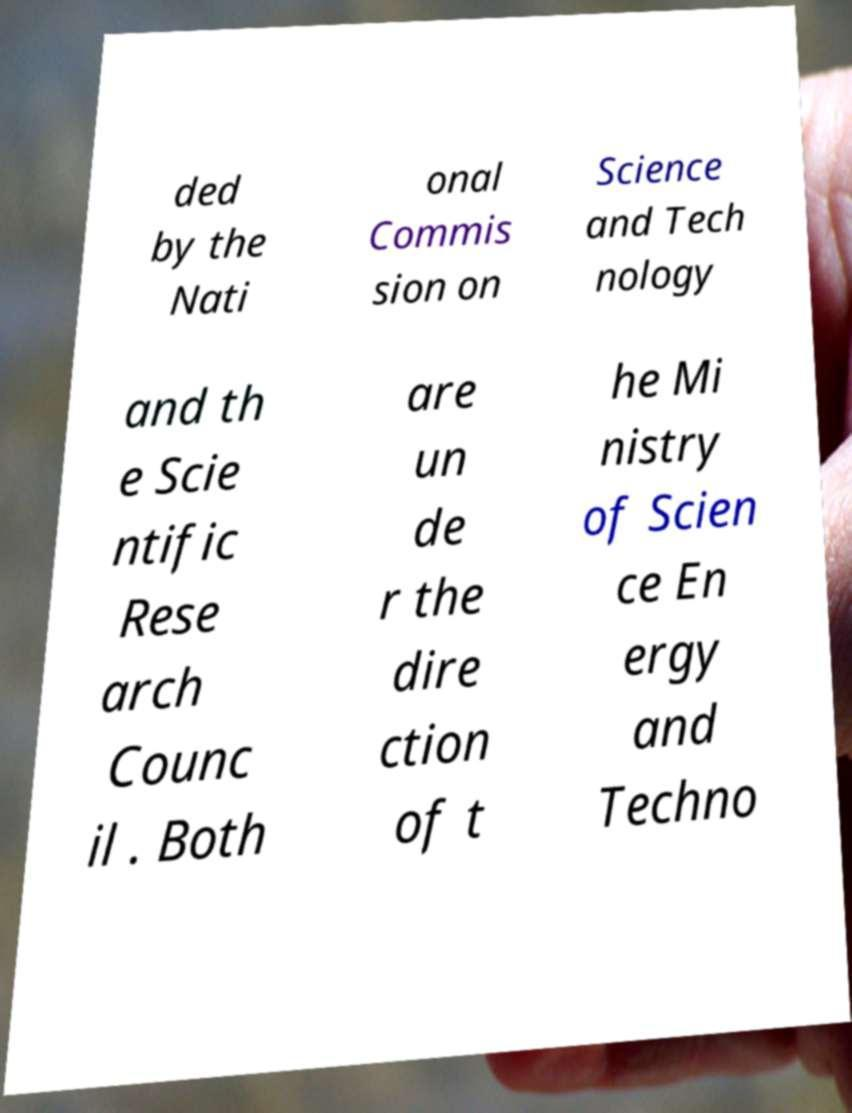Could you assist in decoding the text presented in this image and type it out clearly? ded by the Nati onal Commis sion on Science and Tech nology and th e Scie ntific Rese arch Counc il . Both are un de r the dire ction of t he Mi nistry of Scien ce En ergy and Techno 